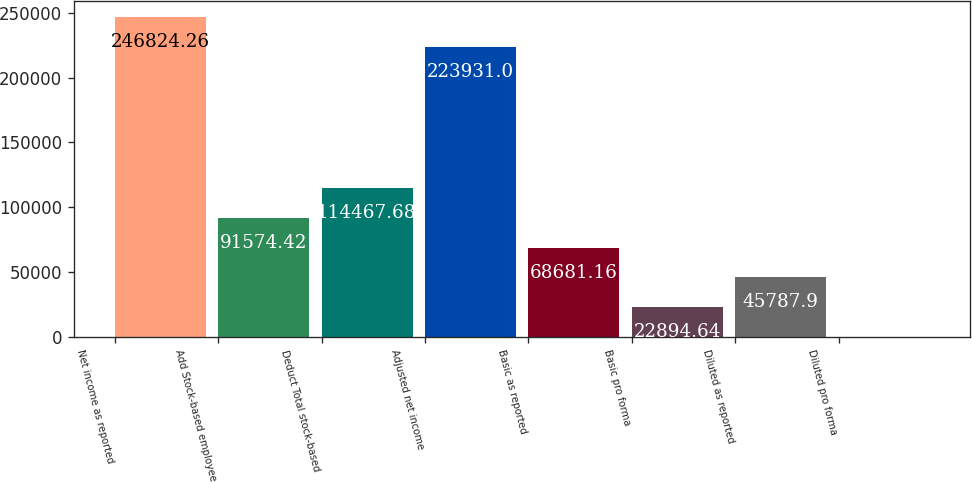Convert chart to OTSL. <chart><loc_0><loc_0><loc_500><loc_500><bar_chart><fcel>Net income as reported<fcel>Add Stock-based employee<fcel>Deduct Total stock-based<fcel>Adjusted net income<fcel>Basic as reported<fcel>Basic pro forma<fcel>Diluted as reported<fcel>Diluted pro forma<nl><fcel>246824<fcel>91574.4<fcel>114468<fcel>223931<fcel>68681.2<fcel>22894.6<fcel>45787.9<fcel>1.38<nl></chart> 